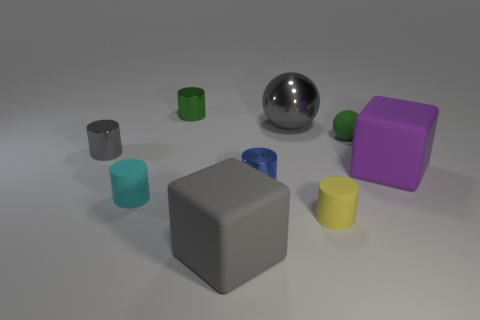Subtract all blue cylinders. How many cylinders are left? 4 Subtract all blocks. How many objects are left? 7 Subtract 1 blue cylinders. How many objects are left? 8 Subtract all large gray shiny objects. Subtract all purple blocks. How many objects are left? 7 Add 1 gray rubber cubes. How many gray rubber cubes are left? 2 Add 7 big gray metallic spheres. How many big gray metallic spheres exist? 8 